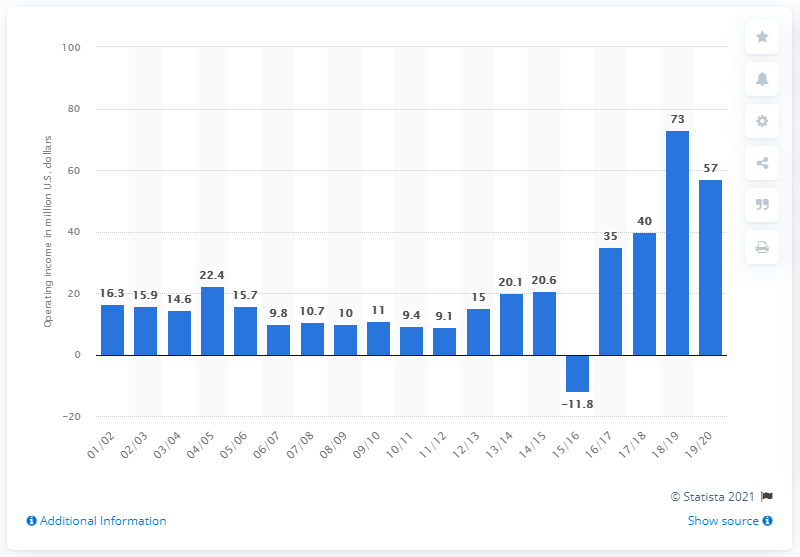Outline some significant characteristics in this image. The operating income of the Los Angeles Clippers in the 2019/20 season was 57 million dollars. 